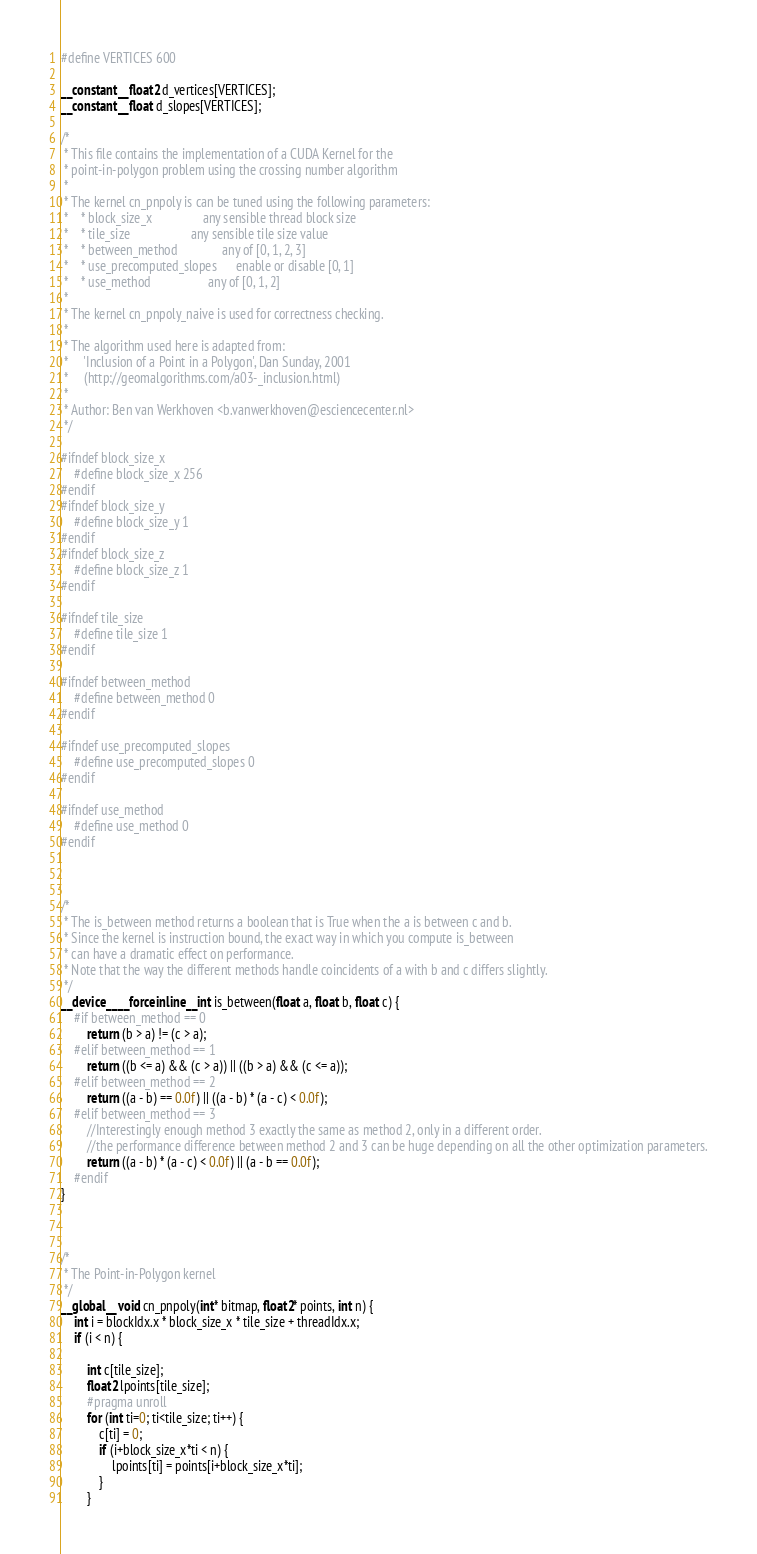Convert code to text. <code><loc_0><loc_0><loc_500><loc_500><_Cuda_>#define VERTICES 600

__constant__ float2 d_vertices[VERTICES];
__constant__ float d_slopes[VERTICES];

/*
 * This file contains the implementation of a CUDA Kernel for the
 * point-in-polygon problem using the crossing number algorithm
 *
 * The kernel cn_pnpoly is can be tuned using the following parameters:
 *    * block_size_x                any sensible thread block size
 *    * tile_size                   any sensible tile size value
 *    * between_method              any of [0, 1, 2, 3]
 *    * use_precomputed_slopes      enable or disable [0, 1]
 *    * use_method                  any of [0, 1, 2]
 *
 * The kernel cn_pnpoly_naive is used for correctness checking.
 *
 * The algorithm used here is adapted from:
 *     'Inclusion of a Point in a Polygon', Dan Sunday, 2001
 *     (http://geomalgorithms.com/a03-_inclusion.html)
 *
 * Author: Ben van Werkhoven <b.vanwerkhoven@esciencecenter.nl>
 */

#ifndef block_size_x
    #define block_size_x 256
#endif
#ifndef block_size_y
    #define block_size_y 1
#endif
#ifndef block_size_z
    #define block_size_z 1
#endif

#ifndef tile_size
    #define tile_size 1
#endif

#ifndef between_method
    #define between_method 0
#endif

#ifndef use_precomputed_slopes
    #define use_precomputed_slopes 0
#endif

#ifndef use_method
    #define use_method 0
#endif



/*
 * The is_between method returns a boolean that is True when the a is between c and b.
 * Since the kernel is instruction bound, the exact way in which you compute is_between
 * can have a dramatic effect on performance.
 * Note that the way the different methods handle coincidents of a with b and c differs slightly.
 */
__device__ __forceinline__ int is_between(float a, float b, float c) {
    #if between_method == 0
        return (b > a) != (c > a);
    #elif between_method == 1
        return ((b <= a) && (c > a)) || ((b > a) && (c <= a));
    #elif between_method == 2
        return ((a - b) == 0.0f) || ((a - b) * (a - c) < 0.0f);
    #elif between_method == 3
        //Interestingly enough method 3 exactly the same as method 2, only in a different order.
        //the performance difference between method 2 and 3 can be huge depending on all the other optimization parameters.
        return ((a - b) * (a - c) < 0.0f) || (a - b == 0.0f);
    #endif
}



/*
 * The Point-in-Polygon kernel
 */
__global__ void cn_pnpoly(int* bitmap, float2* points, int n) {
    int i = blockIdx.x * block_size_x * tile_size + threadIdx.x;
    if (i < n) {

        int c[tile_size];
        float2 lpoints[tile_size];
        #pragma unroll
        for (int ti=0; ti<tile_size; ti++) {
            c[ti] = 0;
            if (i+block_size_x*ti < n) {
                lpoints[ti] = points[i+block_size_x*ti];
            }
        }
</code> 